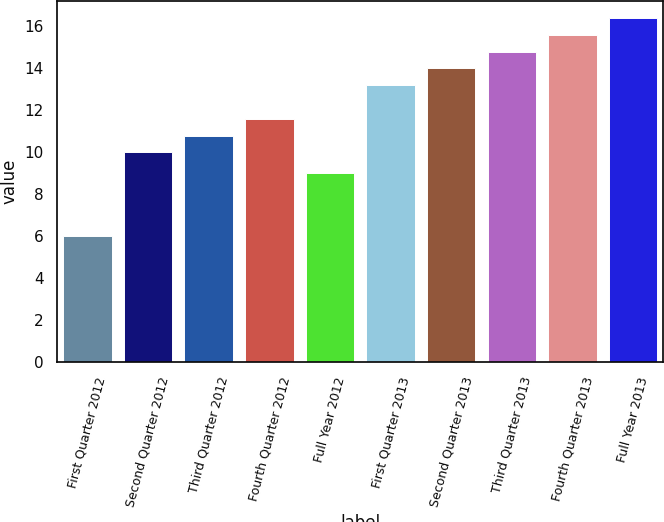Convert chart to OTSL. <chart><loc_0><loc_0><loc_500><loc_500><bar_chart><fcel>First Quarter 2012<fcel>Second Quarter 2012<fcel>Third Quarter 2012<fcel>Fourth Quarter 2012<fcel>Full Year 2012<fcel>First Quarter 2013<fcel>Second Quarter 2013<fcel>Third Quarter 2013<fcel>Fourth Quarter 2013<fcel>Full Year 2013<nl><fcel>6<fcel>10<fcel>10.8<fcel>11.6<fcel>9<fcel>13.2<fcel>14<fcel>14.8<fcel>15.6<fcel>16.4<nl></chart> 